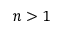Convert formula to latex. <formula><loc_0><loc_0><loc_500><loc_500>n > 1</formula> 